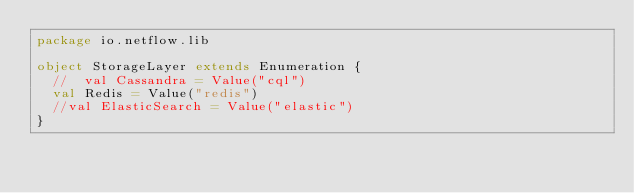Convert code to text. <code><loc_0><loc_0><loc_500><loc_500><_Scala_>package io.netflow.lib

object StorageLayer extends Enumeration {
  //  val Cassandra = Value("cql")
  val Redis = Value("redis")
  //val ElasticSearch = Value("elastic")
}
</code> 